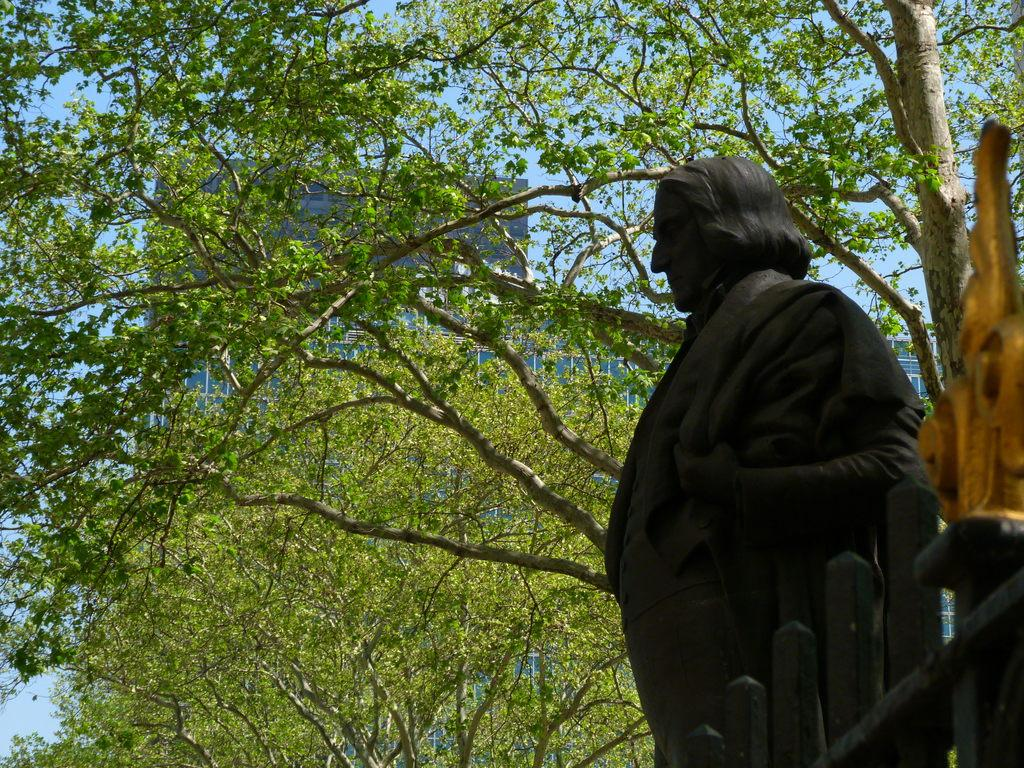What is the main subject of the image? There is a statue in the image. What is the color of the statue? The statue is black in color. What is in front of the statue? There is a railing in front of the statue. What can be seen in the background of the image? There is a tree, a building, and the sky visible in the background of the image. How does the statue crush the steam coming from the eye in the image? There is no steam or eye present in the image, and therefore no such interaction can be observed. 